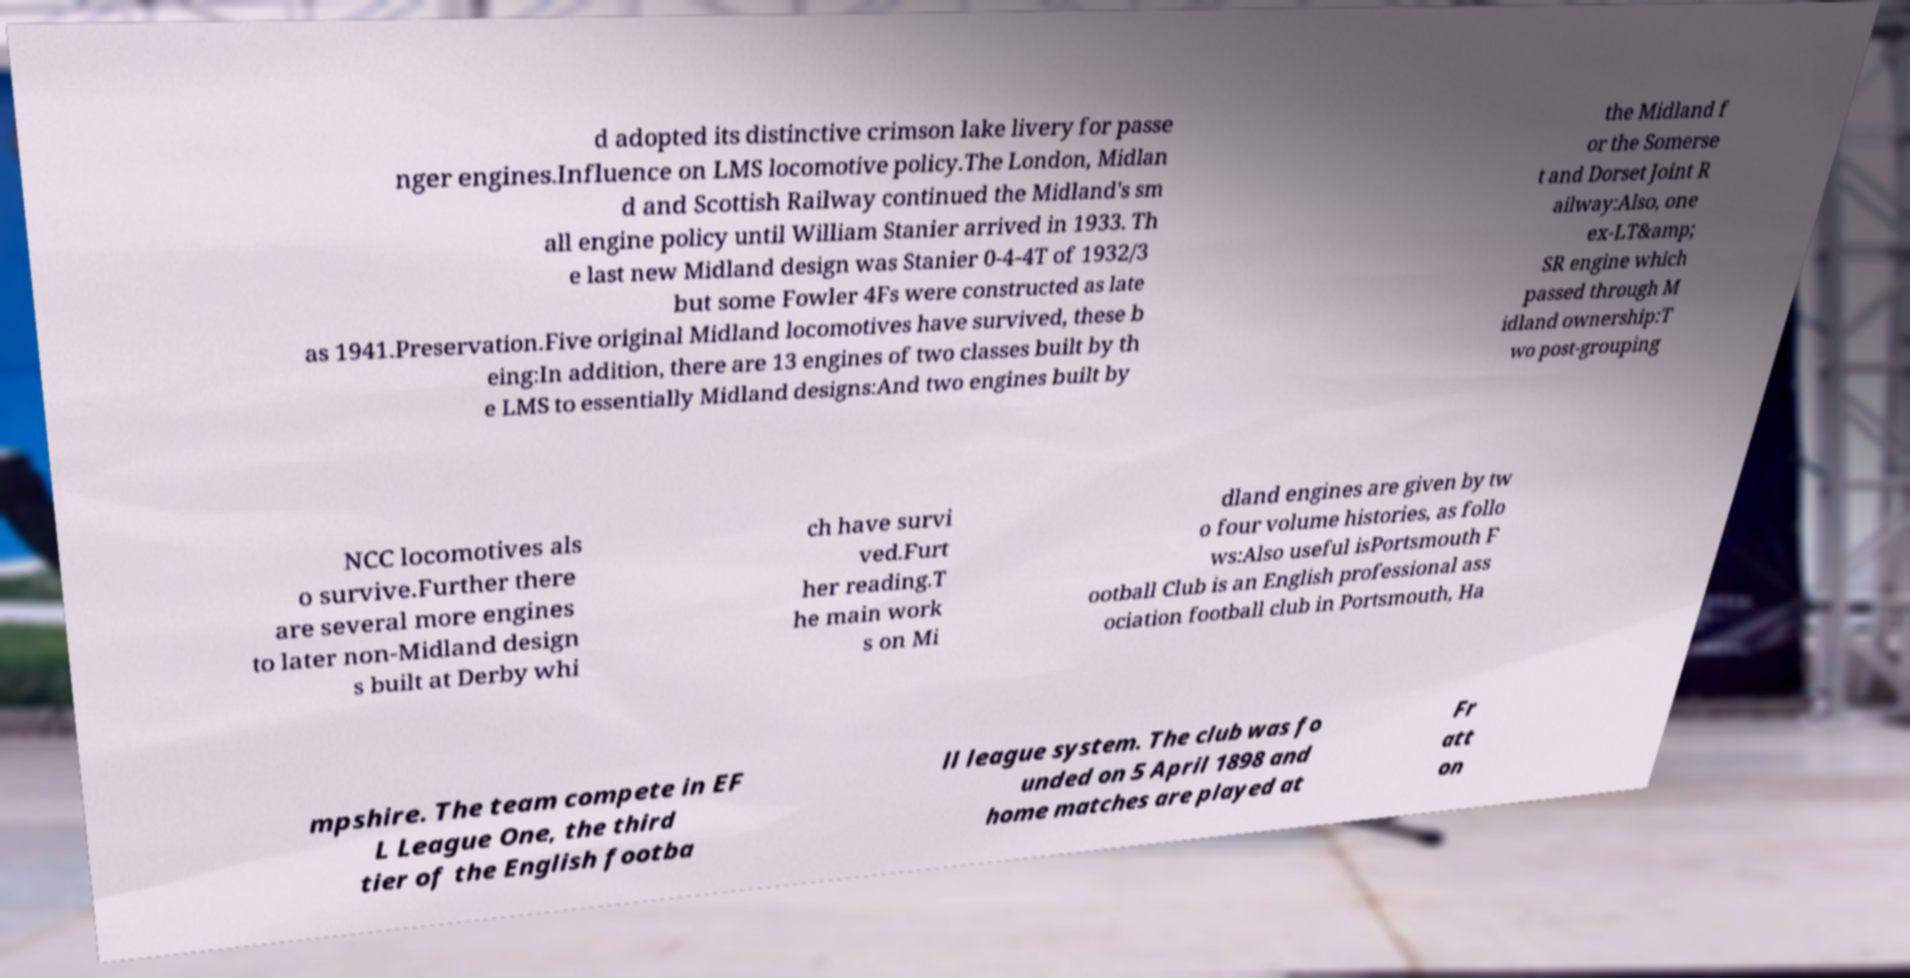Can you read and provide the text displayed in the image?This photo seems to have some interesting text. Can you extract and type it out for me? d adopted its distinctive crimson lake livery for passe nger engines.Influence on LMS locomotive policy.The London, Midlan d and Scottish Railway continued the Midland's sm all engine policy until William Stanier arrived in 1933. Th e last new Midland design was Stanier 0-4-4T of 1932/3 but some Fowler 4Fs were constructed as late as 1941.Preservation.Five original Midland locomotives have survived, these b eing:In addition, there are 13 engines of two classes built by th e LMS to essentially Midland designs:And two engines built by the Midland f or the Somerse t and Dorset Joint R ailway:Also, one ex-LT&amp; SR engine which passed through M idland ownership:T wo post-grouping NCC locomotives als o survive.Further there are several more engines to later non-Midland design s built at Derby whi ch have survi ved.Furt her reading.T he main work s on Mi dland engines are given by tw o four volume histories, as follo ws:Also useful isPortsmouth F ootball Club is an English professional ass ociation football club in Portsmouth, Ha mpshire. The team compete in EF L League One, the third tier of the English footba ll league system. The club was fo unded on 5 April 1898 and home matches are played at Fr att on 